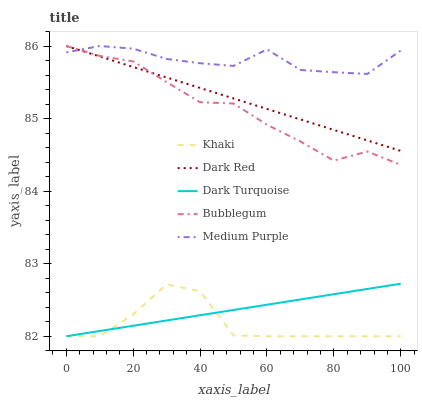Does Khaki have the minimum area under the curve?
Answer yes or no. Yes. Does Medium Purple have the maximum area under the curve?
Answer yes or no. Yes. Does Dark Red have the minimum area under the curve?
Answer yes or no. No. Does Dark Red have the maximum area under the curve?
Answer yes or no. No. Is Dark Turquoise the smoothest?
Answer yes or no. Yes. Is Khaki the roughest?
Answer yes or no. Yes. Is Dark Red the smoothest?
Answer yes or no. No. Is Dark Red the roughest?
Answer yes or no. No. Does Khaki have the lowest value?
Answer yes or no. Yes. Does Dark Red have the lowest value?
Answer yes or no. No. Does Bubblegum have the highest value?
Answer yes or no. Yes. Does Khaki have the highest value?
Answer yes or no. No. Is Khaki less than Dark Red?
Answer yes or no. Yes. Is Medium Purple greater than Dark Turquoise?
Answer yes or no. Yes. Does Bubblegum intersect Medium Purple?
Answer yes or no. Yes. Is Bubblegum less than Medium Purple?
Answer yes or no. No. Is Bubblegum greater than Medium Purple?
Answer yes or no. No. Does Khaki intersect Dark Red?
Answer yes or no. No. 